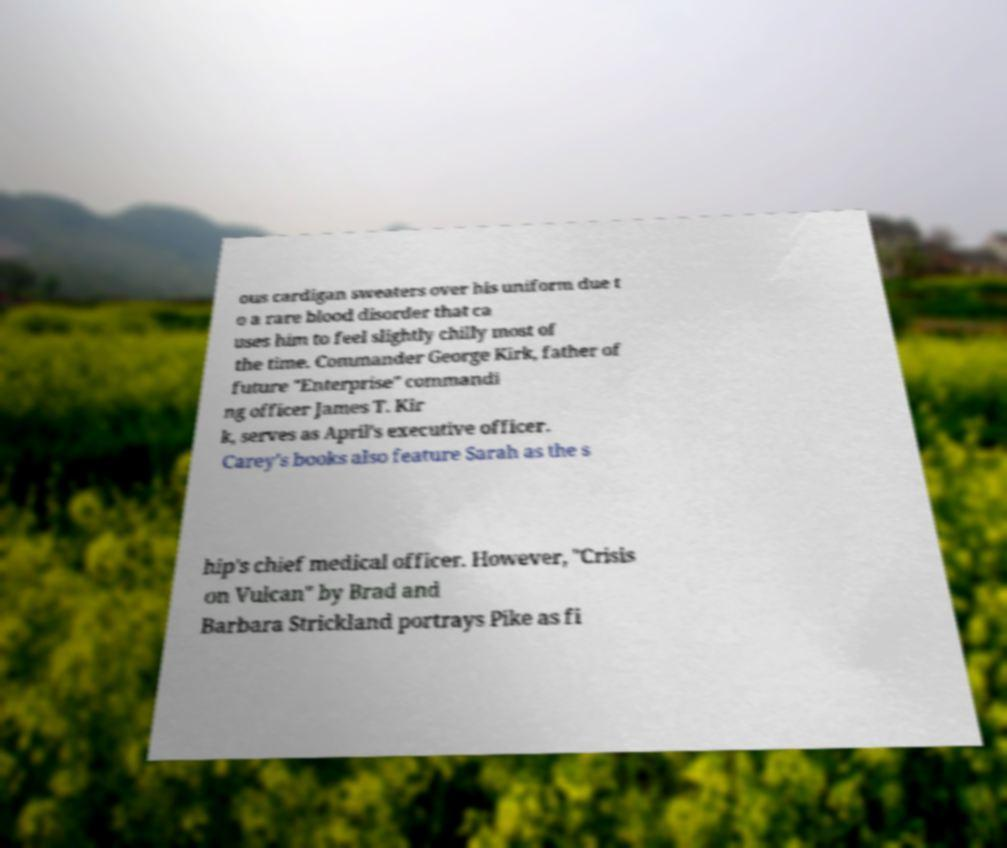There's text embedded in this image that I need extracted. Can you transcribe it verbatim? ous cardigan sweaters over his uniform due t o a rare blood disorder that ca uses him to feel slightly chilly most of the time. Commander George Kirk, father of future "Enterprise" commandi ng officer James T. Kir k, serves as April's executive officer. Carey's books also feature Sarah as the s hip's chief medical officer. However, "Crisis on Vulcan" by Brad and Barbara Strickland portrays Pike as fi 